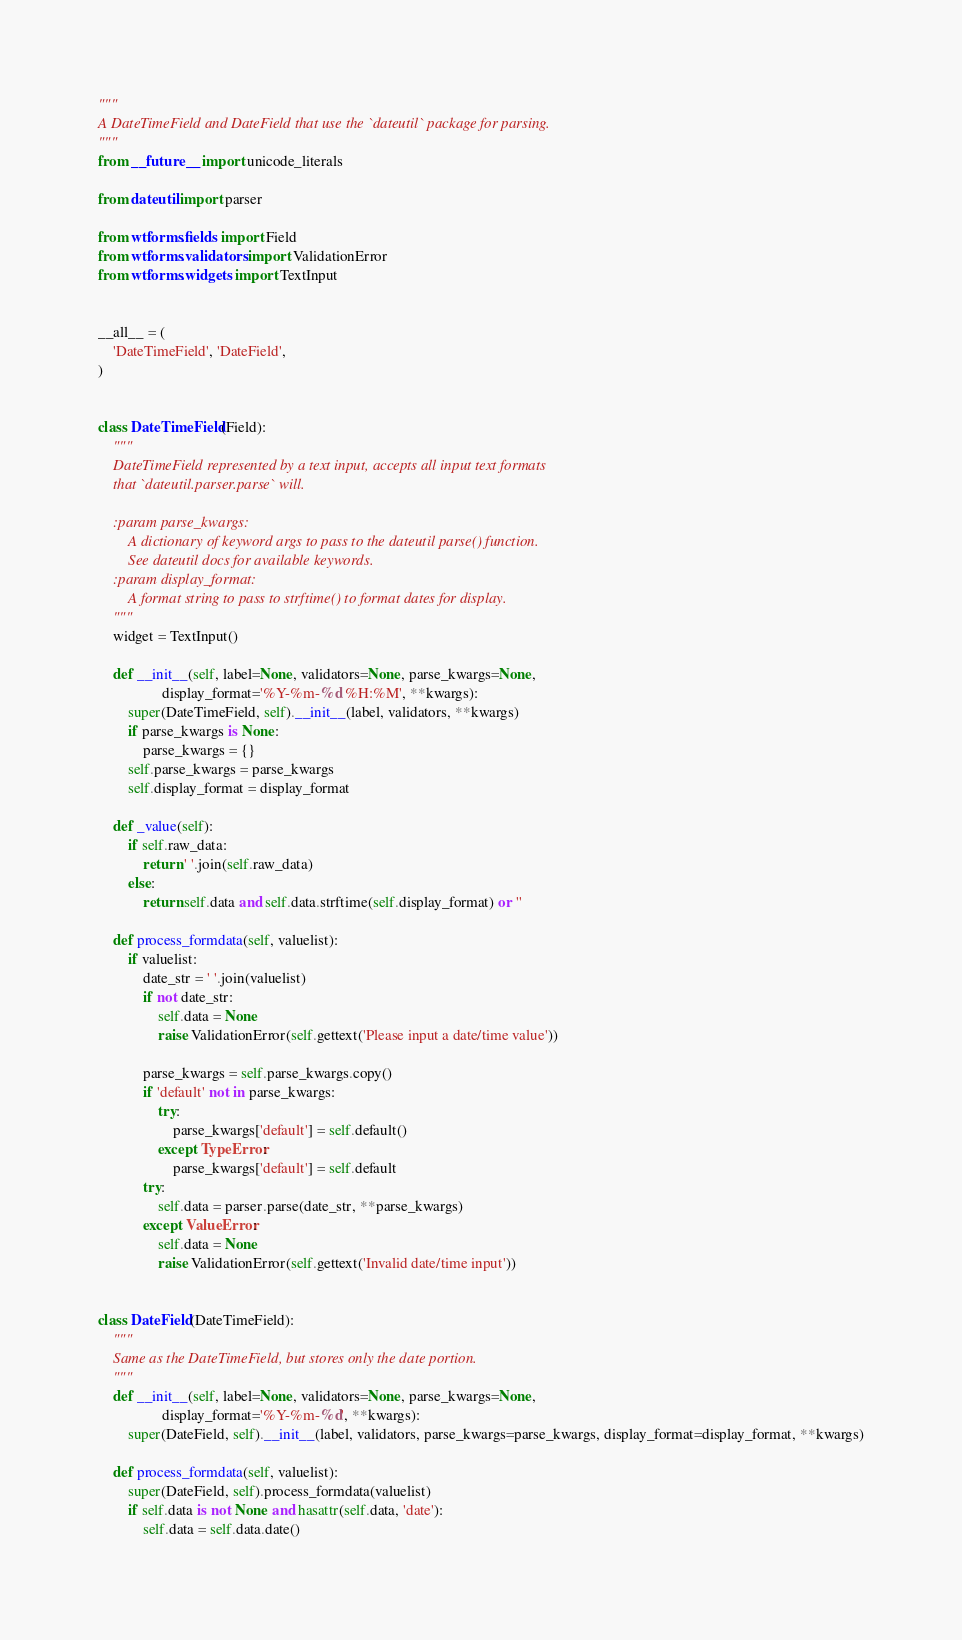<code> <loc_0><loc_0><loc_500><loc_500><_Python_>"""
A DateTimeField and DateField that use the `dateutil` package for parsing.
"""
from __future__ import unicode_literals

from dateutil import parser

from wtforms.fields import Field
from wtforms.validators import ValidationError
from wtforms.widgets import TextInput


__all__ = (
    'DateTimeField', 'DateField',
)


class DateTimeField(Field):
    """
    DateTimeField represented by a text input, accepts all input text formats
    that `dateutil.parser.parse` will.

    :param parse_kwargs:
        A dictionary of keyword args to pass to the dateutil parse() function.
        See dateutil docs for available keywords.
    :param display_format:
        A format string to pass to strftime() to format dates for display.
    """
    widget = TextInput()

    def __init__(self, label=None, validators=None, parse_kwargs=None,
                 display_format='%Y-%m-%d %H:%M', **kwargs):
        super(DateTimeField, self).__init__(label, validators, **kwargs)
        if parse_kwargs is None:
            parse_kwargs = {}
        self.parse_kwargs = parse_kwargs
        self.display_format = display_format

    def _value(self):
        if self.raw_data:
            return ' '.join(self.raw_data)
        else:
            return self.data and self.data.strftime(self.display_format) or ''

    def process_formdata(self, valuelist):
        if valuelist:
            date_str = ' '.join(valuelist)
            if not date_str:
                self.data = None
                raise ValidationError(self.gettext('Please input a date/time value'))

            parse_kwargs = self.parse_kwargs.copy()
            if 'default' not in parse_kwargs:
                try:
                    parse_kwargs['default'] = self.default()
                except TypeError:
                    parse_kwargs['default'] = self.default
            try:
                self.data = parser.parse(date_str, **parse_kwargs)
            except ValueError:
                self.data = None
                raise ValidationError(self.gettext('Invalid date/time input'))


class DateField(DateTimeField):
    """
    Same as the DateTimeField, but stores only the date portion.
    """
    def __init__(self, label=None, validators=None, parse_kwargs=None,
                 display_format='%Y-%m-%d', **kwargs):
        super(DateField, self).__init__(label, validators, parse_kwargs=parse_kwargs, display_format=display_format, **kwargs)

    def process_formdata(self, valuelist):
        super(DateField, self).process_formdata(valuelist)
        if self.data is not None and hasattr(self.data, 'date'):
            self.data = self.data.date()
</code> 